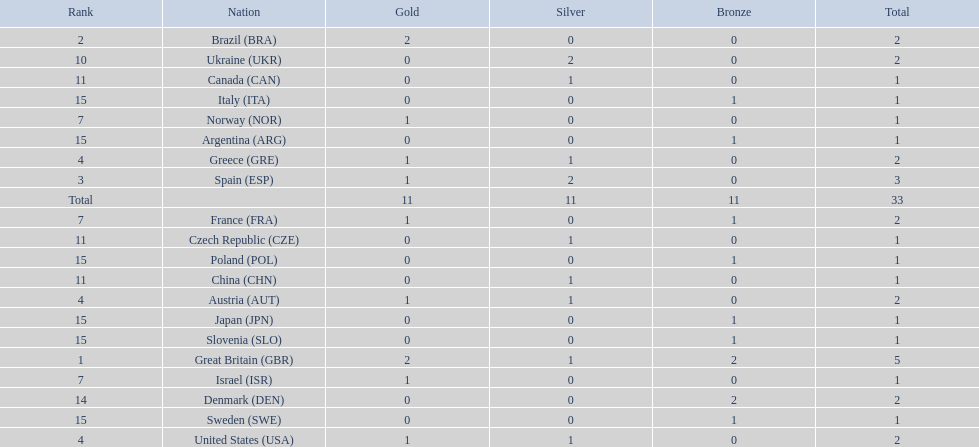What are all of the countries? Great Britain (GBR), Brazil (BRA), Spain (ESP), Austria (AUT), Greece (GRE), United States (USA), France (FRA), Israel (ISR), Norway (NOR), Ukraine (UKR), China (CHN), Czech Republic (CZE), Canada (CAN), Denmark (DEN), Argentina (ARG), Italy (ITA), Japan (JPN), Poland (POL), Slovenia (SLO), Sweden (SWE). Which ones earned a medal? Great Britain (GBR), Brazil (BRA), Spain (ESP), Austria (AUT), Greece (GRE), United States (USA), France (FRA), Israel (ISR), Norway (NOR), Ukraine (UKR), China (CHN), Czech Republic (CZE), Canada (CAN), Denmark (DEN), Argentina (ARG), Italy (ITA), Japan (JPN), Poland (POL), Slovenia (SLO), Sweden (SWE). Which countries earned at least 3 medals? Great Britain (GBR), Spain (ESP). Write the full table. {'header': ['Rank', 'Nation', 'Gold', 'Silver', 'Bronze', 'Total'], 'rows': [['2', 'Brazil\xa0(BRA)', '2', '0', '0', '2'], ['10', 'Ukraine\xa0(UKR)', '0', '2', '0', '2'], ['11', 'Canada\xa0(CAN)', '0', '1', '0', '1'], ['15', 'Italy\xa0(ITA)', '0', '0', '1', '1'], ['7', 'Norway\xa0(NOR)', '1', '0', '0', '1'], ['15', 'Argentina\xa0(ARG)', '0', '0', '1', '1'], ['4', 'Greece\xa0(GRE)', '1', '1', '0', '2'], ['3', 'Spain\xa0(ESP)', '1', '2', '0', '3'], ['Total', '', '11', '11', '11', '33'], ['7', 'France\xa0(FRA)', '1', '0', '1', '2'], ['11', 'Czech Republic\xa0(CZE)', '0', '1', '0', '1'], ['15', 'Poland\xa0(POL)', '0', '0', '1', '1'], ['11', 'China\xa0(CHN)', '0', '1', '0', '1'], ['4', 'Austria\xa0(AUT)', '1', '1', '0', '2'], ['15', 'Japan\xa0(JPN)', '0', '0', '1', '1'], ['15', 'Slovenia\xa0(SLO)', '0', '0', '1', '1'], ['1', 'Great Britain\xa0(GBR)', '2', '1', '2', '5'], ['7', 'Israel\xa0(ISR)', '1', '0', '0', '1'], ['14', 'Denmark\xa0(DEN)', '0', '0', '2', '2'], ['15', 'Sweden\xa0(SWE)', '0', '0', '1', '1'], ['4', 'United States\xa0(USA)', '1', '1', '0', '2']]} Which country earned 3 medals? Spain (ESP). 